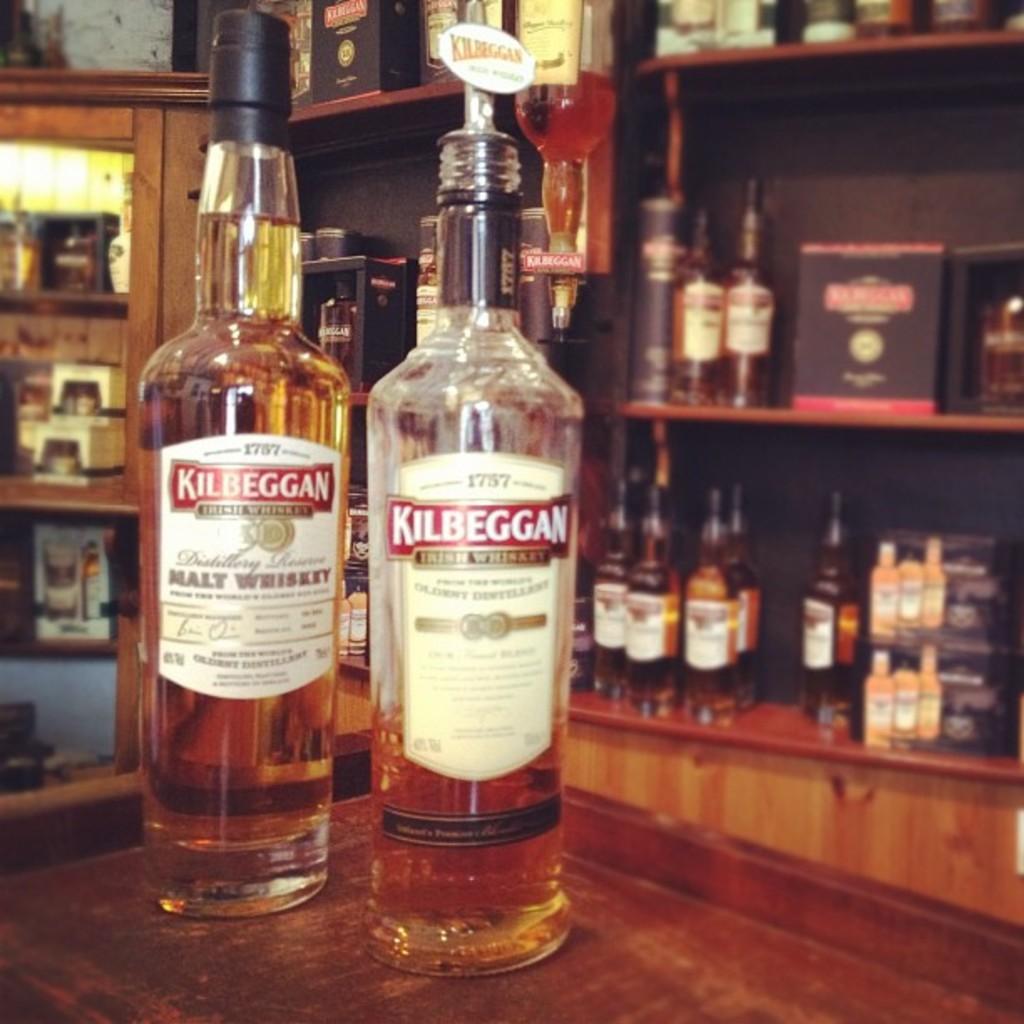What type of whiskey is the bottle on the left?
Ensure brevity in your answer.  Malt. What is the brand of the whiskey?
Make the answer very short. Kilbeggan. 